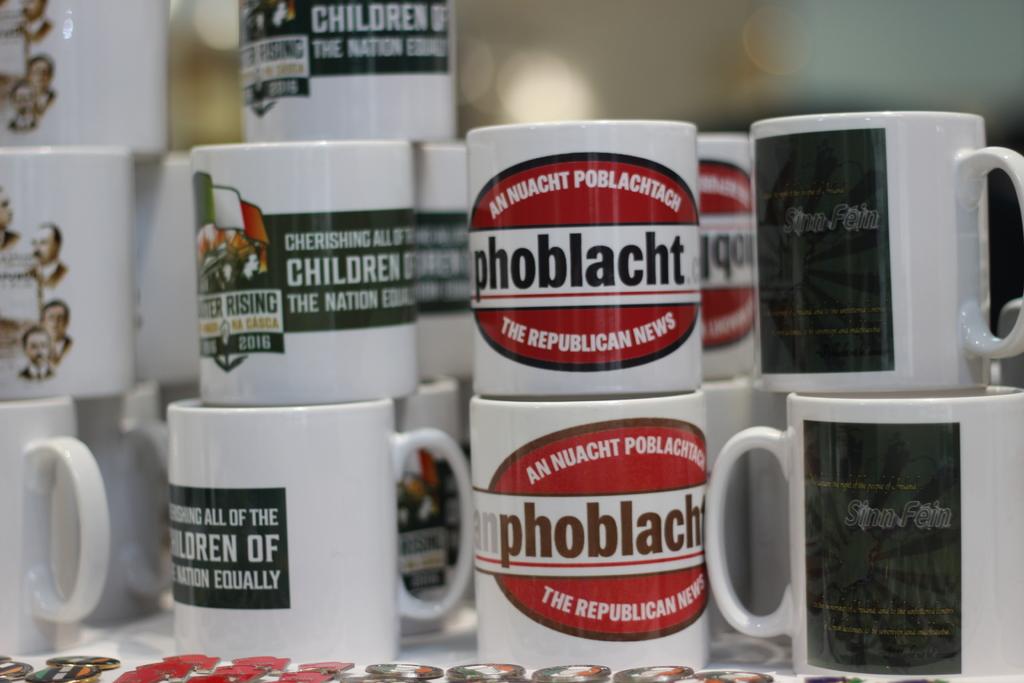What does the one mug tell you to cherish?
Your response must be concise. Children. What word is written in the middle of the second cup from the right?
Offer a very short reply. Phoblacht. 